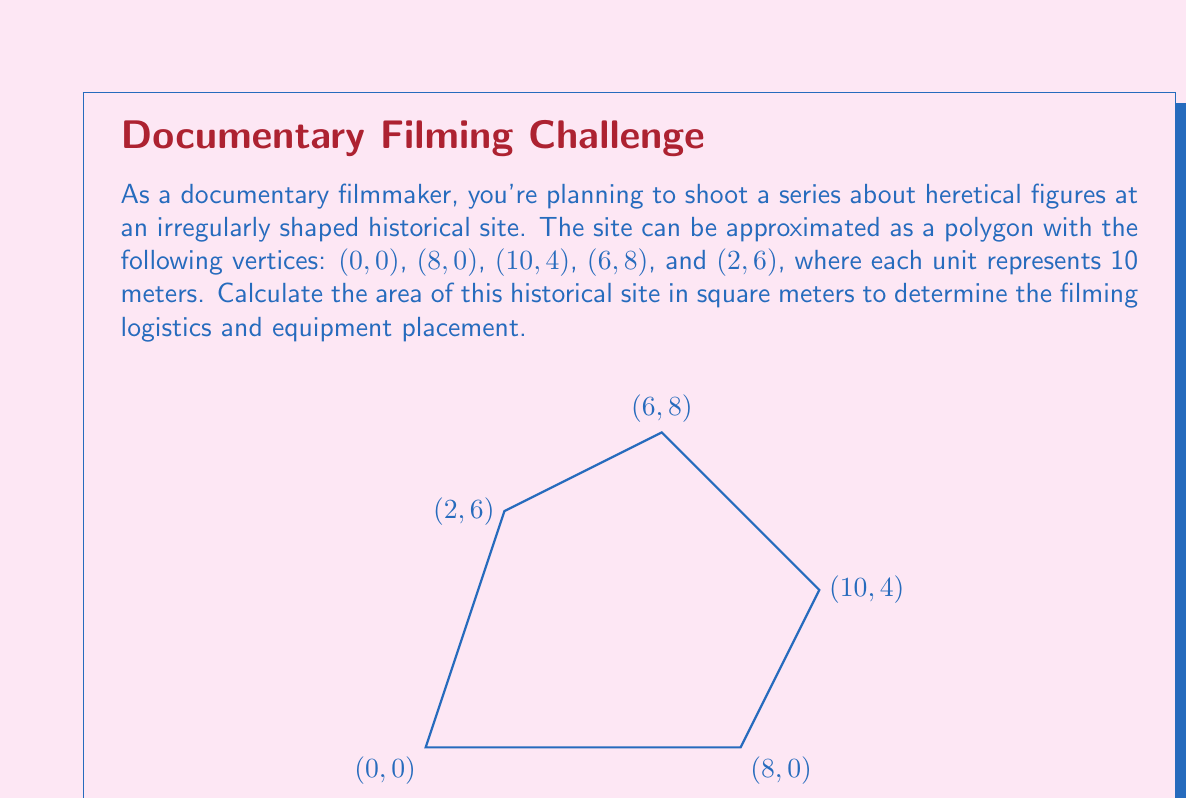Solve this math problem. To solve this problem, we'll use the Shoelace formula (also known as the surveyor's formula) to calculate the area of the irregular polygon. The formula is:

$$ A = \frac{1}{2}|\sum_{i=1}^{n-1} (x_iy_{i+1} - x_{i+1}y_i) + (x_ny_1 - x_1y_n)| $$

Where $(x_i, y_i)$ are the coordinates of the $i$-th vertex.

Let's apply the formula to our polygon:

1) First, let's list our vertices in order:
   $(x_1, y_1) = (0, 0)$
   $(x_2, y_2) = (8, 0)$
   $(x_3, y_3) = (10, 4)$
   $(x_4, y_4) = (6, 8)$
   $(x_5, y_5) = (2, 6)$

2) Now, let's calculate each term in the summation:
   $(0 \cdot 0) - (8 \cdot 0) = 0$
   $(8 \cdot 4) - (10 \cdot 0) = 32$
   $(10 \cdot 8) - (6 \cdot 4) = 56$
   $(6 \cdot 6) - (2 \cdot 8) = 20$
   $(2 \cdot 0) - (0 \cdot 6) = 0$

3) Sum these terms:
   $0 + 32 + 56 + 20 + 0 = 108$

4) Multiply by $\frac{1}{2}$:
   $\frac{1}{2} \cdot 108 = 54$

5) The result, 54, represents the area in square units. Since each unit represents 10 meters, we need to multiply by $10^2 = 100$ to get the area in square meters:

   $54 \cdot 100 = 5400$ square meters
Answer: The area of the historical site is 5400 square meters. 